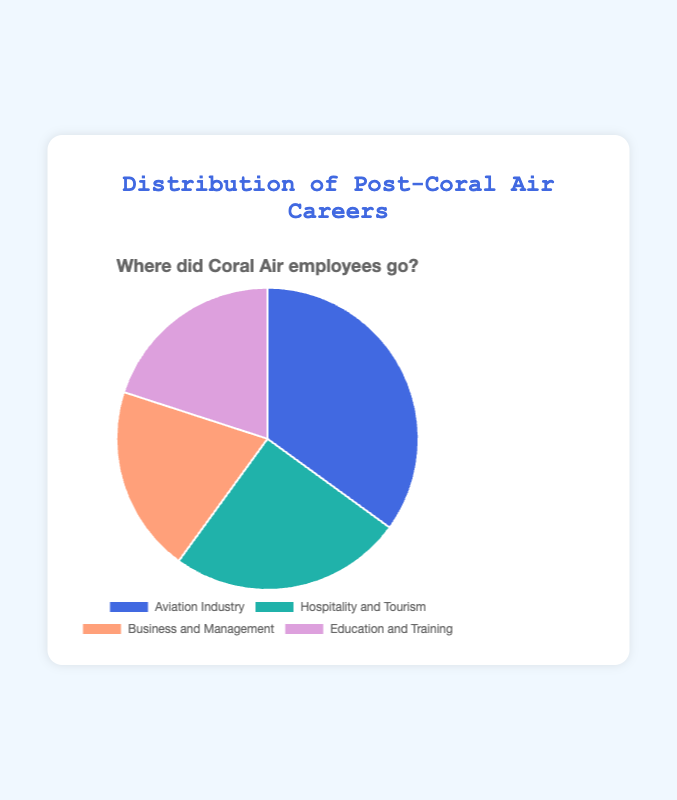What percentage of former Coral Air employees went into Business and Management? To find the percentage, we refer to the Business and Management segment in the pie chart, which is clearly marked as 20%.
Answer: 20% Which career path has the highest number of former Coral Air employees? By examining the segments of the pie chart, the Aviation Industry segment is the largest, labeled as 35%.
Answer: Aviation Industry How much more popular is the Aviation Industry compared to Hospitality and Tourism? The percentage for Aviation Industry is 35%, and for Hospitality and Tourism, it is 25%. The difference can be calculated as 35% - 25% = 10%.
Answer: 10% What is the combined percentage of former employees who moved into Business and Management and Education and Training? Add the percentages for Business and Management (20%) and Education and Training (20%). So, 20% + 20% = 40%.
Answer: 40% Is the percentage of former employees in Hospitality and Tourism greater than in Education and Training? By comparing the segments, Hospitality and Tourism is 25% while Education and Training is 20%. Thus, 25% is greater than 20%.
Answer: Yes Which sector has the least distribution of former Coral Air employees? Comparing all segments in the pie chart, Business and Management and Education and Training both have the lowest percentage at 20%.
Answer: Business and Management and Education and Training What are the colors representing each career path in the pie chart? The pie chart uses distinct colors for each segment: Aviation Industry is blue, Hospitality and Tourism is teal, Business and Management is salmon, and Education and Training is purple.
Answer: Blue, Teal, Salmon, Purple What is the average percentage across all career paths? Add the percentages of all segments (35% + 25% + 20% + 20%) and divide by the number of segments (4). The sum is 100%, and the average is 100% / 4 = 25%.
Answer: 25% Are the segments for Business and Management and Education and Training visually identical in size? Upon examining the pie chart, both segments are 20%, so they appear identical in size.
Answer: Yes 